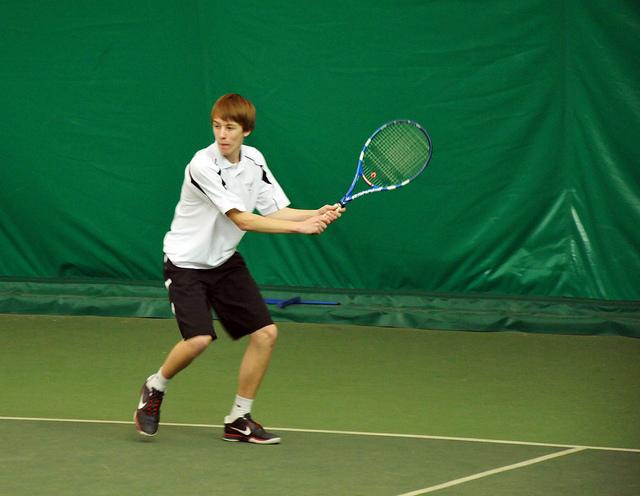Is the boy's goal to throw the racket?
Write a very short answer. No. What is the brand on the sneakers?
Answer briefly. Nike. How many hands is he holding the racket with?
Concise answer only. 2. What sport is this?
Answer briefly. Tennis. 